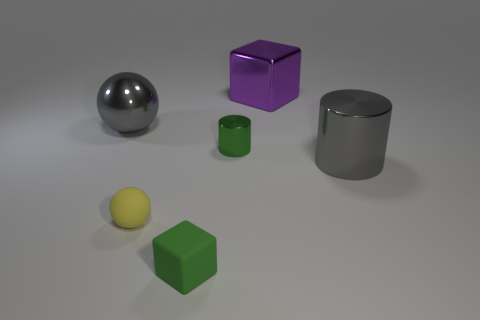Does the large cylinder have the same color as the small metal cylinder?
Make the answer very short. No. What size is the metal thing that is the same color as the metallic ball?
Provide a short and direct response. Large. There is a thing that is the same material as the yellow ball; what color is it?
Offer a terse response. Green. Is the large purple object made of the same material as the big thing that is right of the purple shiny thing?
Keep it short and to the point. Yes. What is the color of the large cylinder?
Provide a succinct answer. Gray. The sphere that is made of the same material as the large purple block is what size?
Your answer should be very brief. Large. There is a shiny cylinder on the left side of the big gray shiny object in front of the big sphere; what number of gray shiny things are right of it?
Offer a terse response. 1. Does the matte block have the same color as the shiny cylinder right of the large purple shiny block?
Your response must be concise. No. There is a big metallic object that is the same color as the big ball; what is its shape?
Your answer should be very brief. Cylinder. There is a ball in front of the shiny object on the left side of the small metallic cylinder that is left of the purple object; what is its material?
Your answer should be very brief. Rubber. 